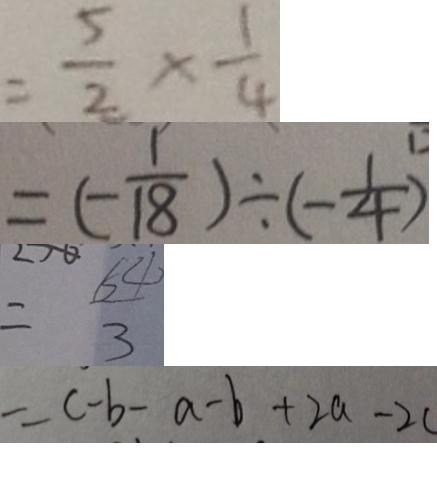Convert formula to latex. <formula><loc_0><loc_0><loc_500><loc_500>= \frac { 5 } { 2 } \times \frac { 1 } { 4 } 
 = ( - \frac { 1 } { 1 8 } ) \div ( - \frac { 1 } { 4 } ) 
 = \frac { 6 4 } { 3 } 
 = c - b - a - b + 2 a - 2 c</formula> 